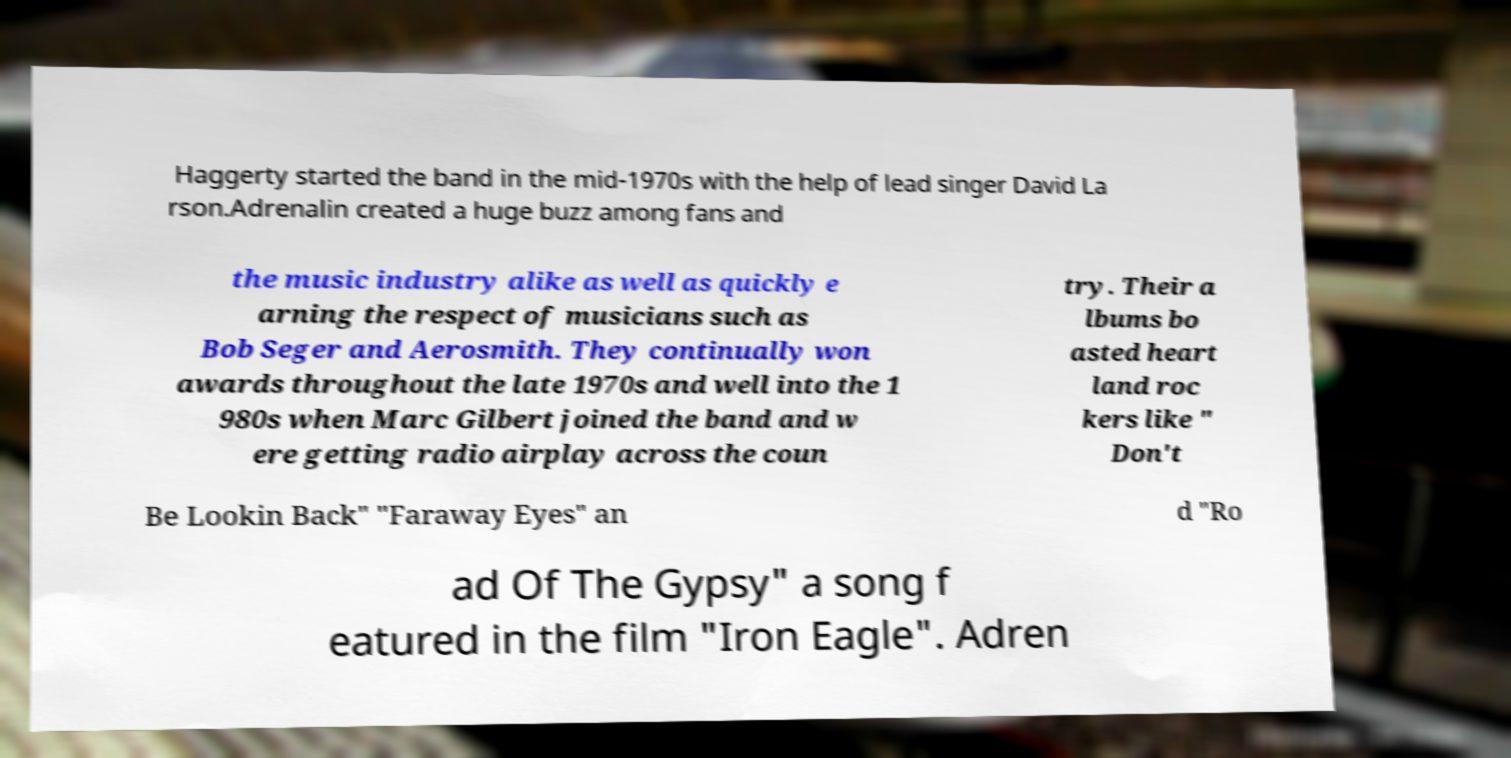For documentation purposes, I need the text within this image transcribed. Could you provide that? Haggerty started the band in the mid-1970s with the help of lead singer David La rson.Adrenalin created a huge buzz among fans and the music industry alike as well as quickly e arning the respect of musicians such as Bob Seger and Aerosmith. They continually won awards throughout the late 1970s and well into the 1 980s when Marc Gilbert joined the band and w ere getting radio airplay across the coun try. Their a lbums bo asted heart land roc kers like " Don't Be Lookin Back" "Faraway Eyes" an d "Ro ad Of The Gypsy" a song f eatured in the film "Iron Eagle". Adren 